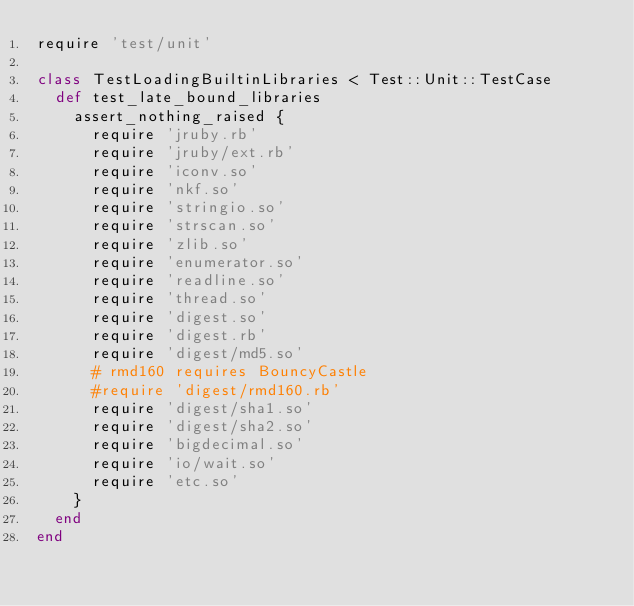<code> <loc_0><loc_0><loc_500><loc_500><_Ruby_>require 'test/unit'

class TestLoadingBuiltinLibraries < Test::Unit::TestCase
  def test_late_bound_libraries
    assert_nothing_raised {
      require 'jruby.rb'
      require 'jruby/ext.rb'
      require 'iconv.so'
      require 'nkf.so'
      require 'stringio.so'
      require 'strscan.so'
      require 'zlib.so'
      require 'enumerator.so'
      require 'readline.so'
      require 'thread.so'
      require 'digest.so'
      require 'digest.rb'
      require 'digest/md5.so'
      # rmd160 requires BouncyCastle
      #require 'digest/rmd160.rb'
      require 'digest/sha1.so'
      require 'digest/sha2.so'
      require 'bigdecimal.so'
      require 'io/wait.so'
      require 'etc.so'
    }
  end
end
</code> 